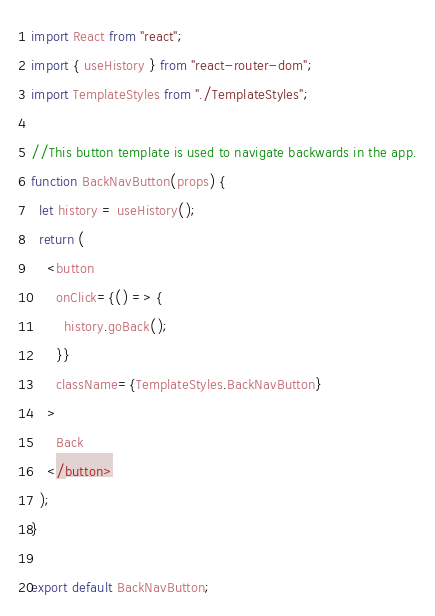Convert code to text. <code><loc_0><loc_0><loc_500><loc_500><_JavaScript_>import React from "react";
import { useHistory } from "react-router-dom";
import TemplateStyles from "./TemplateStyles";

//This button template is used to navigate backwards in the app.
function BackNavButton(props) {
  let history = useHistory();
  return (
    <button
      onClick={() => {
        history.goBack();
      }}
      className={TemplateStyles.BackNavButton}
    >
      Back
    </button>
  );
}

export default BackNavButton;
</code> 